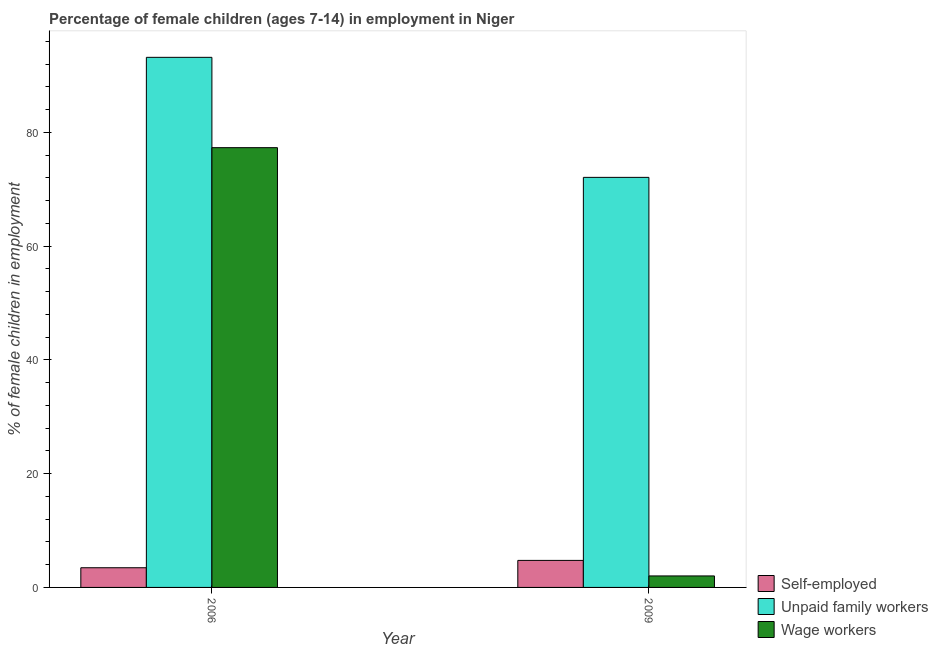How many different coloured bars are there?
Give a very brief answer. 3. Are the number of bars per tick equal to the number of legend labels?
Your answer should be very brief. Yes. Are the number of bars on each tick of the X-axis equal?
Give a very brief answer. Yes. How many bars are there on the 2nd tick from the right?
Your answer should be compact. 3. In how many cases, is the number of bars for a given year not equal to the number of legend labels?
Your answer should be very brief. 0. What is the percentage of children employed as wage workers in 2006?
Your response must be concise. 77.3. Across all years, what is the maximum percentage of self employed children?
Offer a very short reply. 4.75. Across all years, what is the minimum percentage of children employed as unpaid family workers?
Ensure brevity in your answer.  72.08. In which year was the percentage of children employed as unpaid family workers maximum?
Give a very brief answer. 2006. What is the total percentage of self employed children in the graph?
Keep it short and to the point. 8.21. What is the difference between the percentage of self employed children in 2006 and that in 2009?
Offer a terse response. -1.29. What is the difference between the percentage of children employed as wage workers in 2006 and the percentage of children employed as unpaid family workers in 2009?
Give a very brief answer. 75.28. What is the average percentage of children employed as wage workers per year?
Provide a short and direct response. 39.66. In how many years, is the percentage of children employed as unpaid family workers greater than 76 %?
Make the answer very short. 1. What is the ratio of the percentage of children employed as unpaid family workers in 2006 to that in 2009?
Your response must be concise. 1.29. Is the percentage of children employed as unpaid family workers in 2006 less than that in 2009?
Your answer should be compact. No. In how many years, is the percentage of children employed as wage workers greater than the average percentage of children employed as wage workers taken over all years?
Keep it short and to the point. 1. What does the 2nd bar from the left in 2009 represents?
Your response must be concise. Unpaid family workers. What does the 3rd bar from the right in 2006 represents?
Provide a succinct answer. Self-employed. Is it the case that in every year, the sum of the percentage of self employed children and percentage of children employed as unpaid family workers is greater than the percentage of children employed as wage workers?
Make the answer very short. Yes. How many bars are there?
Make the answer very short. 6. Are all the bars in the graph horizontal?
Ensure brevity in your answer.  No. What is the difference between two consecutive major ticks on the Y-axis?
Give a very brief answer. 20. Does the graph contain any zero values?
Offer a terse response. No. Does the graph contain grids?
Your response must be concise. No. Where does the legend appear in the graph?
Provide a succinct answer. Bottom right. How many legend labels are there?
Your answer should be compact. 3. What is the title of the graph?
Your answer should be compact. Percentage of female children (ages 7-14) in employment in Niger. Does "Methane" appear as one of the legend labels in the graph?
Keep it short and to the point. No. What is the label or title of the Y-axis?
Offer a very short reply. % of female children in employment. What is the % of female children in employment in Self-employed in 2006?
Provide a succinct answer. 3.46. What is the % of female children in employment in Unpaid family workers in 2006?
Provide a short and direct response. 93.18. What is the % of female children in employment of Wage workers in 2006?
Provide a succinct answer. 77.3. What is the % of female children in employment of Self-employed in 2009?
Provide a succinct answer. 4.75. What is the % of female children in employment in Unpaid family workers in 2009?
Offer a terse response. 72.08. What is the % of female children in employment in Wage workers in 2009?
Your response must be concise. 2.02. Across all years, what is the maximum % of female children in employment of Self-employed?
Keep it short and to the point. 4.75. Across all years, what is the maximum % of female children in employment in Unpaid family workers?
Your response must be concise. 93.18. Across all years, what is the maximum % of female children in employment of Wage workers?
Offer a terse response. 77.3. Across all years, what is the minimum % of female children in employment in Self-employed?
Your answer should be compact. 3.46. Across all years, what is the minimum % of female children in employment in Unpaid family workers?
Make the answer very short. 72.08. Across all years, what is the minimum % of female children in employment of Wage workers?
Your response must be concise. 2.02. What is the total % of female children in employment of Self-employed in the graph?
Give a very brief answer. 8.21. What is the total % of female children in employment of Unpaid family workers in the graph?
Provide a succinct answer. 165.26. What is the total % of female children in employment in Wage workers in the graph?
Your answer should be compact. 79.32. What is the difference between the % of female children in employment in Self-employed in 2006 and that in 2009?
Make the answer very short. -1.29. What is the difference between the % of female children in employment in Unpaid family workers in 2006 and that in 2009?
Offer a very short reply. 21.1. What is the difference between the % of female children in employment of Wage workers in 2006 and that in 2009?
Provide a succinct answer. 75.28. What is the difference between the % of female children in employment of Self-employed in 2006 and the % of female children in employment of Unpaid family workers in 2009?
Your response must be concise. -68.62. What is the difference between the % of female children in employment of Self-employed in 2006 and the % of female children in employment of Wage workers in 2009?
Your answer should be compact. 1.44. What is the difference between the % of female children in employment of Unpaid family workers in 2006 and the % of female children in employment of Wage workers in 2009?
Provide a short and direct response. 91.16. What is the average % of female children in employment of Self-employed per year?
Provide a succinct answer. 4.11. What is the average % of female children in employment of Unpaid family workers per year?
Keep it short and to the point. 82.63. What is the average % of female children in employment of Wage workers per year?
Offer a terse response. 39.66. In the year 2006, what is the difference between the % of female children in employment of Self-employed and % of female children in employment of Unpaid family workers?
Keep it short and to the point. -89.72. In the year 2006, what is the difference between the % of female children in employment of Self-employed and % of female children in employment of Wage workers?
Provide a succinct answer. -73.84. In the year 2006, what is the difference between the % of female children in employment of Unpaid family workers and % of female children in employment of Wage workers?
Offer a terse response. 15.88. In the year 2009, what is the difference between the % of female children in employment of Self-employed and % of female children in employment of Unpaid family workers?
Keep it short and to the point. -67.33. In the year 2009, what is the difference between the % of female children in employment of Self-employed and % of female children in employment of Wage workers?
Ensure brevity in your answer.  2.73. In the year 2009, what is the difference between the % of female children in employment of Unpaid family workers and % of female children in employment of Wage workers?
Your response must be concise. 70.06. What is the ratio of the % of female children in employment in Self-employed in 2006 to that in 2009?
Provide a short and direct response. 0.73. What is the ratio of the % of female children in employment of Unpaid family workers in 2006 to that in 2009?
Make the answer very short. 1.29. What is the ratio of the % of female children in employment in Wage workers in 2006 to that in 2009?
Your response must be concise. 38.27. What is the difference between the highest and the second highest % of female children in employment of Self-employed?
Your response must be concise. 1.29. What is the difference between the highest and the second highest % of female children in employment in Unpaid family workers?
Offer a terse response. 21.1. What is the difference between the highest and the second highest % of female children in employment in Wage workers?
Provide a succinct answer. 75.28. What is the difference between the highest and the lowest % of female children in employment of Self-employed?
Provide a succinct answer. 1.29. What is the difference between the highest and the lowest % of female children in employment in Unpaid family workers?
Provide a succinct answer. 21.1. What is the difference between the highest and the lowest % of female children in employment in Wage workers?
Make the answer very short. 75.28. 